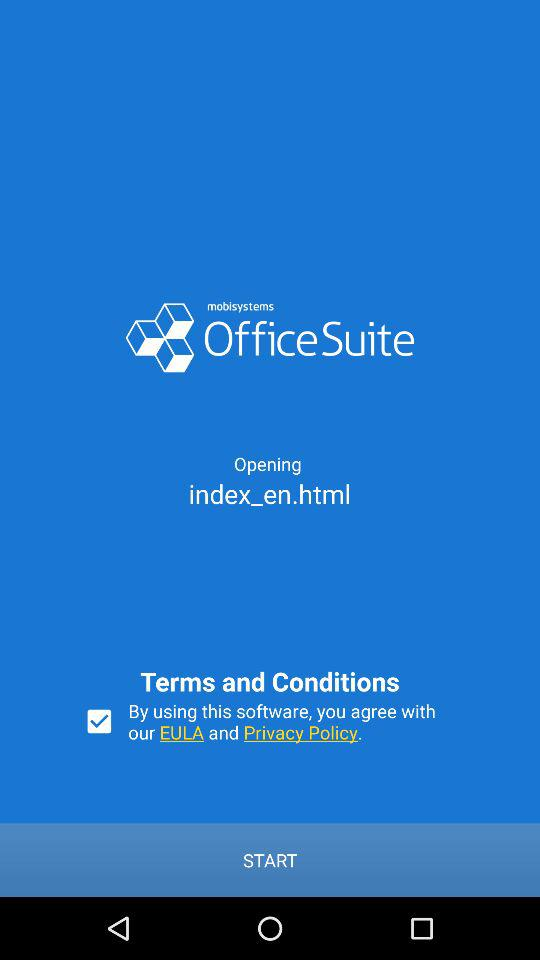What is the long form of EULA?
When the provided information is insufficient, respond with <no answer>. <no answer> 